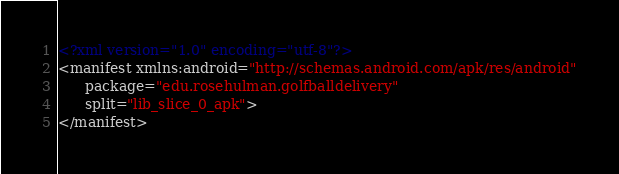<code> <loc_0><loc_0><loc_500><loc_500><_XML_><?xml version="1.0" encoding="utf-8"?>
<manifest xmlns:android="http://schemas.android.com/apk/res/android"
      package="edu.rosehulman.golfballdelivery"
      split="lib_slice_0_apk">
</manifest>
</code> 